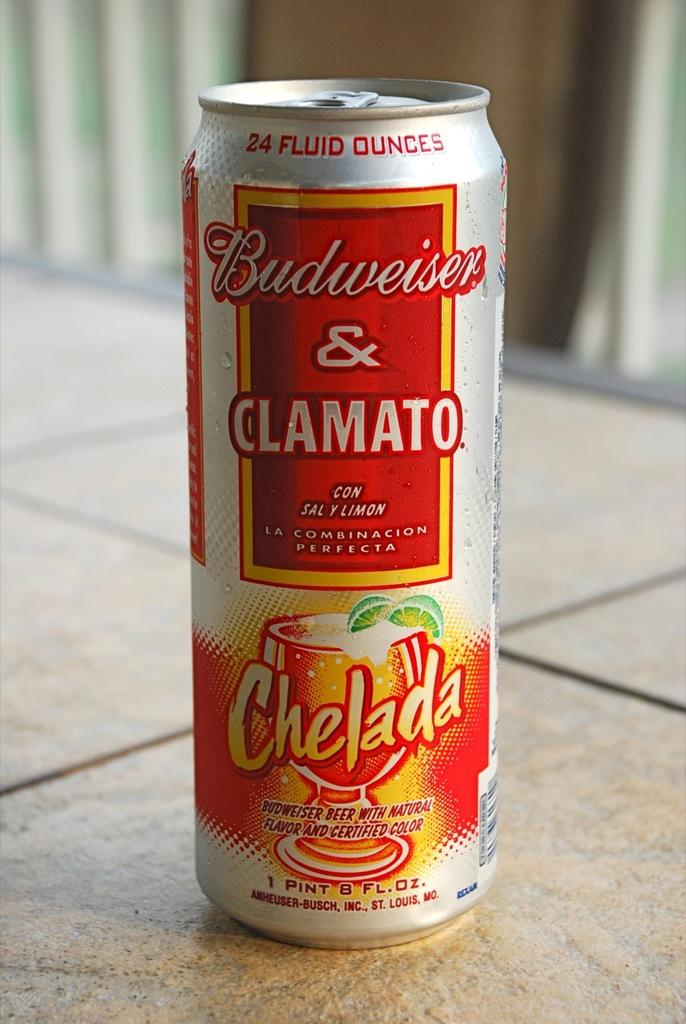Provide a one-sentence caption for the provided image. a Budweiser can with the word Chelada on it. 